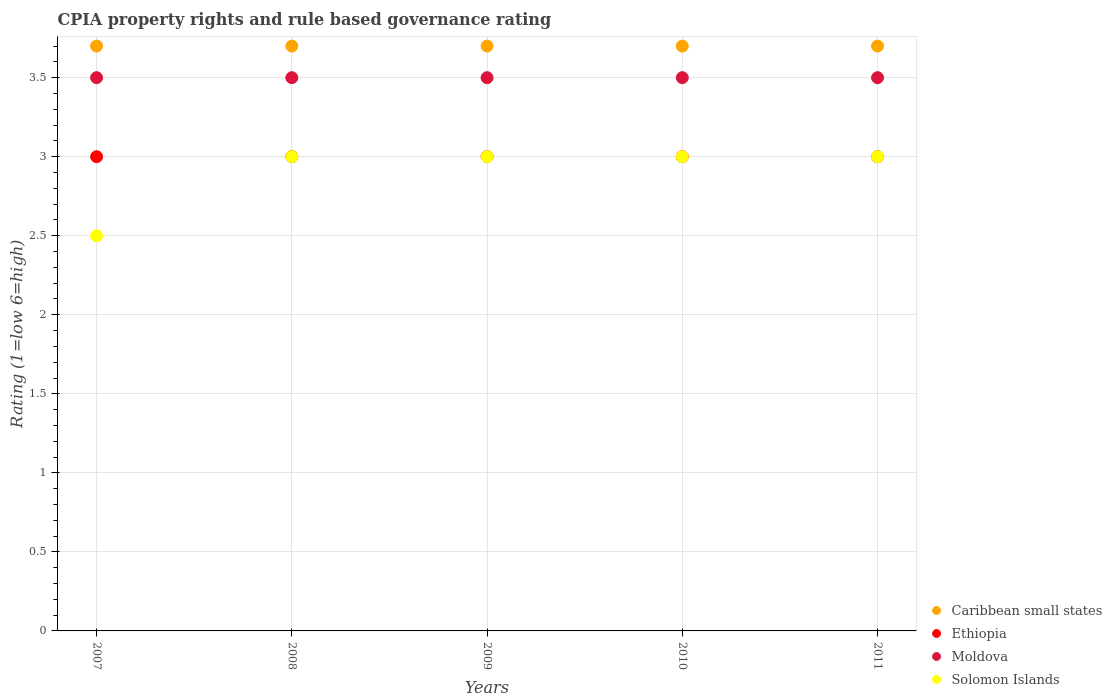How many different coloured dotlines are there?
Offer a terse response. 4. Across all years, what is the maximum CPIA rating in Caribbean small states?
Offer a terse response. 3.7. Across all years, what is the minimum CPIA rating in Solomon Islands?
Your answer should be compact. 2.5. In which year was the CPIA rating in Ethiopia minimum?
Your answer should be very brief. 2007. What is the total CPIA rating in Ethiopia in the graph?
Offer a terse response. 15. What is the difference between the CPIA rating in Moldova in 2007 and the CPIA rating in Caribbean small states in 2010?
Offer a very short reply. -0.2. Is the CPIA rating in Moldova in 2009 less than that in 2010?
Your answer should be compact. No. In how many years, is the CPIA rating in Caribbean small states greater than the average CPIA rating in Caribbean small states taken over all years?
Offer a terse response. 0. Is the sum of the CPIA rating in Solomon Islands in 2008 and 2011 greater than the maximum CPIA rating in Caribbean small states across all years?
Your answer should be compact. Yes. Is it the case that in every year, the sum of the CPIA rating in Caribbean small states and CPIA rating in Solomon Islands  is greater than the sum of CPIA rating in Ethiopia and CPIA rating in Moldova?
Provide a succinct answer. Yes. Is it the case that in every year, the sum of the CPIA rating in Solomon Islands and CPIA rating in Ethiopia  is greater than the CPIA rating in Moldova?
Your answer should be compact. Yes. Does the CPIA rating in Solomon Islands monotonically increase over the years?
Offer a very short reply. No. Is the CPIA rating in Caribbean small states strictly greater than the CPIA rating in Ethiopia over the years?
Provide a succinct answer. Yes. Is the CPIA rating in Solomon Islands strictly less than the CPIA rating in Caribbean small states over the years?
Offer a terse response. Yes. How many dotlines are there?
Provide a short and direct response. 4. How many years are there in the graph?
Offer a terse response. 5. Are the values on the major ticks of Y-axis written in scientific E-notation?
Your answer should be compact. No. Does the graph contain any zero values?
Provide a succinct answer. No. Where does the legend appear in the graph?
Ensure brevity in your answer.  Bottom right. How many legend labels are there?
Ensure brevity in your answer.  4. How are the legend labels stacked?
Provide a succinct answer. Vertical. What is the title of the graph?
Provide a succinct answer. CPIA property rights and rule based governance rating. What is the label or title of the Y-axis?
Offer a very short reply. Rating (1=low 6=high). What is the Rating (1=low 6=high) in Solomon Islands in 2007?
Your response must be concise. 2.5. What is the Rating (1=low 6=high) in Caribbean small states in 2008?
Provide a succinct answer. 3.7. What is the Rating (1=low 6=high) in Ethiopia in 2008?
Offer a very short reply. 3. What is the Rating (1=low 6=high) in Moldova in 2008?
Give a very brief answer. 3.5. What is the Rating (1=low 6=high) of Solomon Islands in 2008?
Offer a very short reply. 3. What is the Rating (1=low 6=high) in Caribbean small states in 2009?
Give a very brief answer. 3.7. What is the Rating (1=low 6=high) in Moldova in 2009?
Make the answer very short. 3.5. What is the Rating (1=low 6=high) of Caribbean small states in 2010?
Provide a succinct answer. 3.7. What is the Rating (1=low 6=high) of Ethiopia in 2011?
Your response must be concise. 3. Across all years, what is the maximum Rating (1=low 6=high) of Caribbean small states?
Provide a short and direct response. 3.7. Across all years, what is the minimum Rating (1=low 6=high) in Ethiopia?
Ensure brevity in your answer.  3. Across all years, what is the minimum Rating (1=low 6=high) in Solomon Islands?
Offer a very short reply. 2.5. What is the total Rating (1=low 6=high) of Moldova in the graph?
Provide a short and direct response. 17.5. What is the total Rating (1=low 6=high) in Solomon Islands in the graph?
Your response must be concise. 14.5. What is the difference between the Rating (1=low 6=high) in Moldova in 2007 and that in 2008?
Provide a short and direct response. 0. What is the difference between the Rating (1=low 6=high) in Caribbean small states in 2007 and that in 2010?
Offer a terse response. 0. What is the difference between the Rating (1=low 6=high) of Ethiopia in 2007 and that in 2010?
Offer a very short reply. 0. What is the difference between the Rating (1=low 6=high) in Caribbean small states in 2008 and that in 2009?
Your answer should be compact. 0. What is the difference between the Rating (1=low 6=high) in Ethiopia in 2008 and that in 2009?
Provide a short and direct response. 0. What is the difference between the Rating (1=low 6=high) of Moldova in 2008 and that in 2009?
Provide a succinct answer. 0. What is the difference between the Rating (1=low 6=high) of Solomon Islands in 2008 and that in 2009?
Offer a terse response. 0. What is the difference between the Rating (1=low 6=high) in Caribbean small states in 2008 and that in 2010?
Provide a succinct answer. 0. What is the difference between the Rating (1=low 6=high) in Moldova in 2008 and that in 2010?
Offer a very short reply. 0. What is the difference between the Rating (1=low 6=high) of Solomon Islands in 2008 and that in 2010?
Offer a terse response. 0. What is the difference between the Rating (1=low 6=high) of Ethiopia in 2008 and that in 2011?
Offer a terse response. 0. What is the difference between the Rating (1=low 6=high) in Solomon Islands in 2008 and that in 2011?
Your response must be concise. 0. What is the difference between the Rating (1=low 6=high) in Ethiopia in 2009 and that in 2011?
Your response must be concise. 0. What is the difference between the Rating (1=low 6=high) of Ethiopia in 2010 and that in 2011?
Your answer should be compact. 0. What is the difference between the Rating (1=low 6=high) in Moldova in 2010 and that in 2011?
Keep it short and to the point. 0. What is the difference between the Rating (1=low 6=high) in Solomon Islands in 2010 and that in 2011?
Offer a very short reply. 0. What is the difference between the Rating (1=low 6=high) of Caribbean small states in 2007 and the Rating (1=low 6=high) of Ethiopia in 2008?
Ensure brevity in your answer.  0.7. What is the difference between the Rating (1=low 6=high) in Caribbean small states in 2007 and the Rating (1=low 6=high) in Moldova in 2008?
Offer a terse response. 0.2. What is the difference between the Rating (1=low 6=high) in Ethiopia in 2007 and the Rating (1=low 6=high) in Solomon Islands in 2008?
Provide a short and direct response. 0. What is the difference between the Rating (1=low 6=high) of Moldova in 2007 and the Rating (1=low 6=high) of Solomon Islands in 2008?
Provide a short and direct response. 0.5. What is the difference between the Rating (1=low 6=high) of Caribbean small states in 2007 and the Rating (1=low 6=high) of Moldova in 2009?
Give a very brief answer. 0.2. What is the difference between the Rating (1=low 6=high) in Caribbean small states in 2007 and the Rating (1=low 6=high) in Solomon Islands in 2009?
Your answer should be very brief. 0.7. What is the difference between the Rating (1=low 6=high) of Moldova in 2007 and the Rating (1=low 6=high) of Solomon Islands in 2009?
Your response must be concise. 0.5. What is the difference between the Rating (1=low 6=high) of Caribbean small states in 2007 and the Rating (1=low 6=high) of Moldova in 2010?
Provide a succinct answer. 0.2. What is the difference between the Rating (1=low 6=high) in Ethiopia in 2007 and the Rating (1=low 6=high) in Moldova in 2010?
Keep it short and to the point. -0.5. What is the difference between the Rating (1=low 6=high) of Ethiopia in 2007 and the Rating (1=low 6=high) of Solomon Islands in 2010?
Your answer should be compact. 0. What is the difference between the Rating (1=low 6=high) of Moldova in 2007 and the Rating (1=low 6=high) of Solomon Islands in 2010?
Give a very brief answer. 0.5. What is the difference between the Rating (1=low 6=high) of Caribbean small states in 2007 and the Rating (1=low 6=high) of Solomon Islands in 2011?
Provide a short and direct response. 0.7. What is the difference between the Rating (1=low 6=high) in Ethiopia in 2007 and the Rating (1=low 6=high) in Solomon Islands in 2011?
Offer a very short reply. 0. What is the difference between the Rating (1=low 6=high) of Caribbean small states in 2008 and the Rating (1=low 6=high) of Ethiopia in 2009?
Give a very brief answer. 0.7. What is the difference between the Rating (1=low 6=high) in Caribbean small states in 2008 and the Rating (1=low 6=high) in Solomon Islands in 2009?
Ensure brevity in your answer.  0.7. What is the difference between the Rating (1=low 6=high) of Caribbean small states in 2008 and the Rating (1=low 6=high) of Ethiopia in 2010?
Offer a very short reply. 0.7. What is the difference between the Rating (1=low 6=high) in Caribbean small states in 2008 and the Rating (1=low 6=high) in Moldova in 2010?
Provide a succinct answer. 0.2. What is the difference between the Rating (1=low 6=high) of Ethiopia in 2008 and the Rating (1=low 6=high) of Solomon Islands in 2010?
Your answer should be very brief. 0. What is the difference between the Rating (1=low 6=high) in Moldova in 2008 and the Rating (1=low 6=high) in Solomon Islands in 2010?
Your answer should be compact. 0.5. What is the difference between the Rating (1=low 6=high) of Caribbean small states in 2008 and the Rating (1=low 6=high) of Ethiopia in 2011?
Ensure brevity in your answer.  0.7. What is the difference between the Rating (1=low 6=high) in Caribbean small states in 2008 and the Rating (1=low 6=high) in Solomon Islands in 2011?
Your answer should be compact. 0.7. What is the difference between the Rating (1=low 6=high) in Ethiopia in 2008 and the Rating (1=low 6=high) in Solomon Islands in 2011?
Offer a terse response. 0. What is the difference between the Rating (1=low 6=high) in Caribbean small states in 2009 and the Rating (1=low 6=high) in Ethiopia in 2010?
Give a very brief answer. 0.7. What is the difference between the Rating (1=low 6=high) of Caribbean small states in 2009 and the Rating (1=low 6=high) of Moldova in 2010?
Your answer should be very brief. 0.2. What is the difference between the Rating (1=low 6=high) in Caribbean small states in 2009 and the Rating (1=low 6=high) in Solomon Islands in 2010?
Offer a terse response. 0.7. What is the difference between the Rating (1=low 6=high) in Ethiopia in 2009 and the Rating (1=low 6=high) in Moldova in 2010?
Provide a succinct answer. -0.5. What is the difference between the Rating (1=low 6=high) of Caribbean small states in 2009 and the Rating (1=low 6=high) of Ethiopia in 2011?
Ensure brevity in your answer.  0.7. What is the difference between the Rating (1=low 6=high) in Caribbean small states in 2009 and the Rating (1=low 6=high) in Moldova in 2011?
Give a very brief answer. 0.2. What is the difference between the Rating (1=low 6=high) of Ethiopia in 2009 and the Rating (1=low 6=high) of Solomon Islands in 2011?
Your answer should be compact. 0. What is the difference between the Rating (1=low 6=high) in Caribbean small states in 2010 and the Rating (1=low 6=high) in Ethiopia in 2011?
Offer a very short reply. 0.7. What is the difference between the Rating (1=low 6=high) in Caribbean small states in 2010 and the Rating (1=low 6=high) in Moldova in 2011?
Offer a terse response. 0.2. What is the difference between the Rating (1=low 6=high) of Caribbean small states in 2010 and the Rating (1=low 6=high) of Solomon Islands in 2011?
Your response must be concise. 0.7. What is the difference between the Rating (1=low 6=high) in Moldova in 2010 and the Rating (1=low 6=high) in Solomon Islands in 2011?
Keep it short and to the point. 0.5. What is the average Rating (1=low 6=high) of Caribbean small states per year?
Keep it short and to the point. 3.7. What is the average Rating (1=low 6=high) of Moldova per year?
Your answer should be very brief. 3.5. In the year 2007, what is the difference between the Rating (1=low 6=high) in Caribbean small states and Rating (1=low 6=high) in Ethiopia?
Offer a very short reply. 0.7. In the year 2007, what is the difference between the Rating (1=low 6=high) of Caribbean small states and Rating (1=low 6=high) of Moldova?
Make the answer very short. 0.2. In the year 2007, what is the difference between the Rating (1=low 6=high) in Ethiopia and Rating (1=low 6=high) in Solomon Islands?
Give a very brief answer. 0.5. In the year 2008, what is the difference between the Rating (1=low 6=high) in Caribbean small states and Rating (1=low 6=high) in Moldova?
Ensure brevity in your answer.  0.2. In the year 2008, what is the difference between the Rating (1=low 6=high) in Caribbean small states and Rating (1=low 6=high) in Solomon Islands?
Ensure brevity in your answer.  0.7. In the year 2008, what is the difference between the Rating (1=low 6=high) in Ethiopia and Rating (1=low 6=high) in Solomon Islands?
Keep it short and to the point. 0. In the year 2010, what is the difference between the Rating (1=low 6=high) in Caribbean small states and Rating (1=low 6=high) in Moldova?
Ensure brevity in your answer.  0.2. In the year 2010, what is the difference between the Rating (1=low 6=high) of Caribbean small states and Rating (1=low 6=high) of Solomon Islands?
Give a very brief answer. 0.7. In the year 2010, what is the difference between the Rating (1=low 6=high) of Ethiopia and Rating (1=low 6=high) of Moldova?
Provide a succinct answer. -0.5. In the year 2010, what is the difference between the Rating (1=low 6=high) of Ethiopia and Rating (1=low 6=high) of Solomon Islands?
Your answer should be compact. 0. In the year 2011, what is the difference between the Rating (1=low 6=high) in Caribbean small states and Rating (1=low 6=high) in Moldova?
Offer a terse response. 0.2. What is the ratio of the Rating (1=low 6=high) in Caribbean small states in 2007 to that in 2008?
Keep it short and to the point. 1. What is the ratio of the Rating (1=low 6=high) in Moldova in 2007 to that in 2008?
Make the answer very short. 1. What is the ratio of the Rating (1=low 6=high) of Solomon Islands in 2007 to that in 2008?
Your response must be concise. 0.83. What is the ratio of the Rating (1=low 6=high) of Caribbean small states in 2007 to that in 2009?
Provide a short and direct response. 1. What is the ratio of the Rating (1=low 6=high) in Moldova in 2007 to that in 2009?
Your response must be concise. 1. What is the ratio of the Rating (1=low 6=high) in Caribbean small states in 2007 to that in 2011?
Keep it short and to the point. 1. What is the ratio of the Rating (1=low 6=high) in Moldova in 2007 to that in 2011?
Your answer should be compact. 1. What is the ratio of the Rating (1=low 6=high) in Solomon Islands in 2007 to that in 2011?
Your response must be concise. 0.83. What is the ratio of the Rating (1=low 6=high) in Caribbean small states in 2008 to that in 2009?
Make the answer very short. 1. What is the ratio of the Rating (1=low 6=high) of Caribbean small states in 2008 to that in 2011?
Ensure brevity in your answer.  1. What is the ratio of the Rating (1=low 6=high) of Ethiopia in 2008 to that in 2011?
Your answer should be very brief. 1. What is the ratio of the Rating (1=low 6=high) of Solomon Islands in 2008 to that in 2011?
Keep it short and to the point. 1. What is the ratio of the Rating (1=low 6=high) in Caribbean small states in 2009 to that in 2010?
Give a very brief answer. 1. What is the ratio of the Rating (1=low 6=high) in Ethiopia in 2009 to that in 2011?
Provide a short and direct response. 1. What is the ratio of the Rating (1=low 6=high) in Solomon Islands in 2009 to that in 2011?
Provide a succinct answer. 1. What is the ratio of the Rating (1=low 6=high) in Moldova in 2010 to that in 2011?
Your answer should be compact. 1. What is the ratio of the Rating (1=low 6=high) in Solomon Islands in 2010 to that in 2011?
Your response must be concise. 1. What is the difference between the highest and the second highest Rating (1=low 6=high) in Caribbean small states?
Provide a succinct answer. 0. What is the difference between the highest and the second highest Rating (1=low 6=high) of Ethiopia?
Make the answer very short. 0. What is the difference between the highest and the second highest Rating (1=low 6=high) in Moldova?
Ensure brevity in your answer.  0. What is the difference between the highest and the second highest Rating (1=low 6=high) of Solomon Islands?
Offer a terse response. 0. What is the difference between the highest and the lowest Rating (1=low 6=high) in Caribbean small states?
Ensure brevity in your answer.  0. 